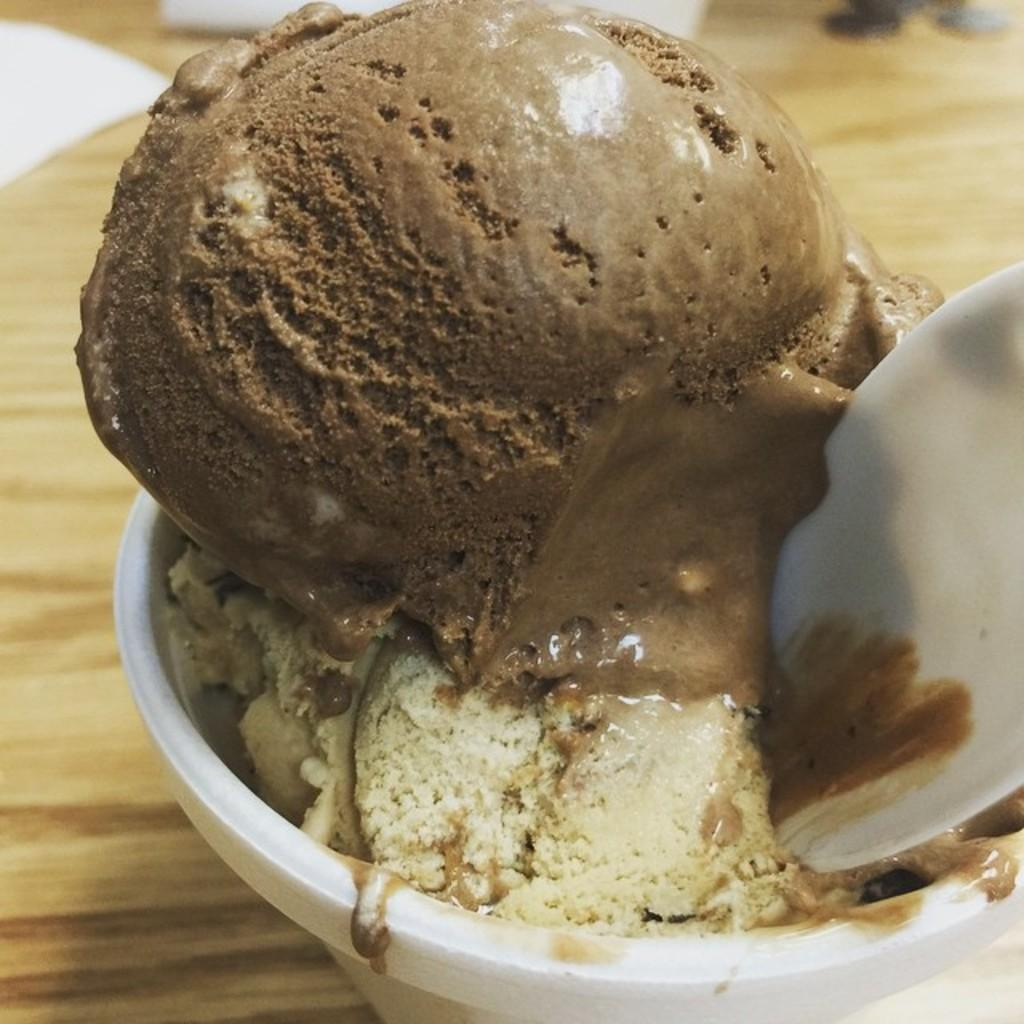What is the main subject in the image? There is an ice-cream cup in the image. Where is the ice-cream cup located? The ice-cream cup is on a table. What sign is displayed on the ice-cream cup in the image? There is no sign displayed on the ice-cream cup in the image. 